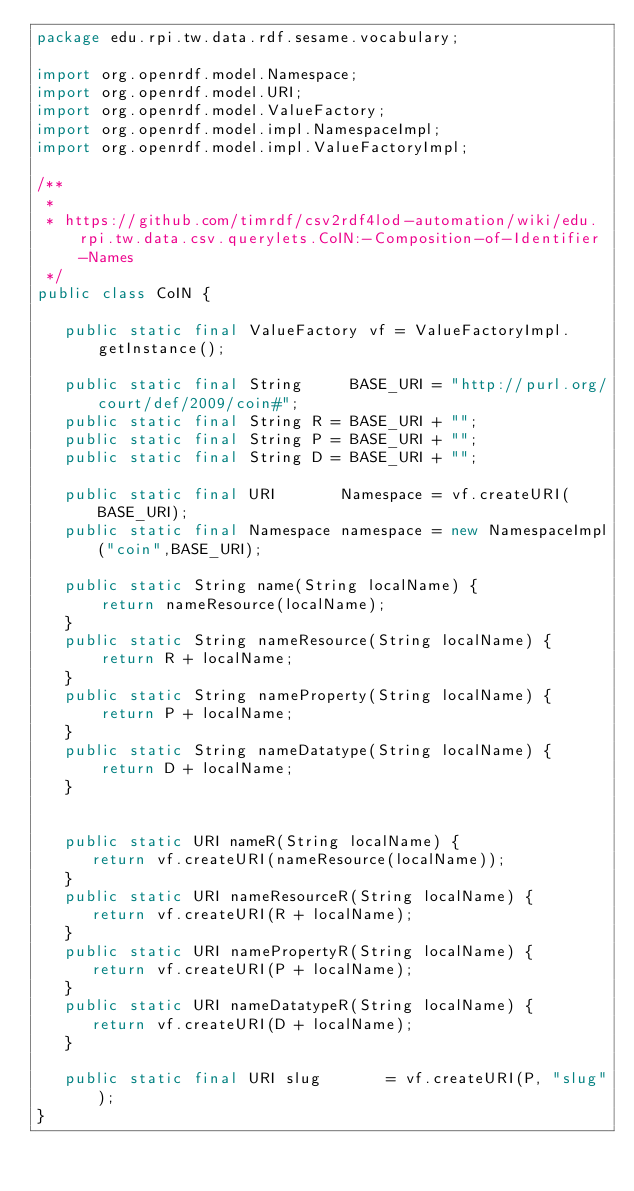<code> <loc_0><loc_0><loc_500><loc_500><_Java_>package edu.rpi.tw.data.rdf.sesame.vocabulary;

import org.openrdf.model.Namespace;
import org.openrdf.model.URI;
import org.openrdf.model.ValueFactory;
import org.openrdf.model.impl.NamespaceImpl;
import org.openrdf.model.impl.ValueFactoryImpl;

/**
 * 
 * https://github.com/timrdf/csv2rdf4lod-automation/wiki/edu.rpi.tw.data.csv.querylets.CoIN:-Composition-of-Identifier-Names
 */
public class CoIN {
   
   public static final ValueFactory vf = ValueFactoryImpl.getInstance();

   public static final String     BASE_URI = "http://purl.org/court/def/2009/coin#";
   public static final String R = BASE_URI + "";
   public static final String P = BASE_URI + "";
   public static final String D = BASE_URI + "";

   public static final URI       Namespace = vf.createURI(BASE_URI);
   public static final Namespace namespace = new NamespaceImpl("coin",BASE_URI);
   
   public static String name(String localName) {
       return nameResource(localName);
   }
   public static String nameResource(String localName) {
       return R + localName;
   }
   public static String nameProperty(String localName) {
       return P + localName;
   }
   public static String nameDatatype(String localName) {
       return D + localName;
   }
   

   public static URI nameR(String localName) {
      return vf.createURI(nameResource(localName));
   }
   public static URI nameResourceR(String localName) {
      return vf.createURI(R + localName);
   }
   public static URI namePropertyR(String localName) {
      return vf.createURI(P + localName);
   }
   public static URI nameDatatypeR(String localName) {
      return vf.createURI(D + localName);
   }
 
   public static final URI slug       = vf.createURI(P, "slug");
}
</code> 